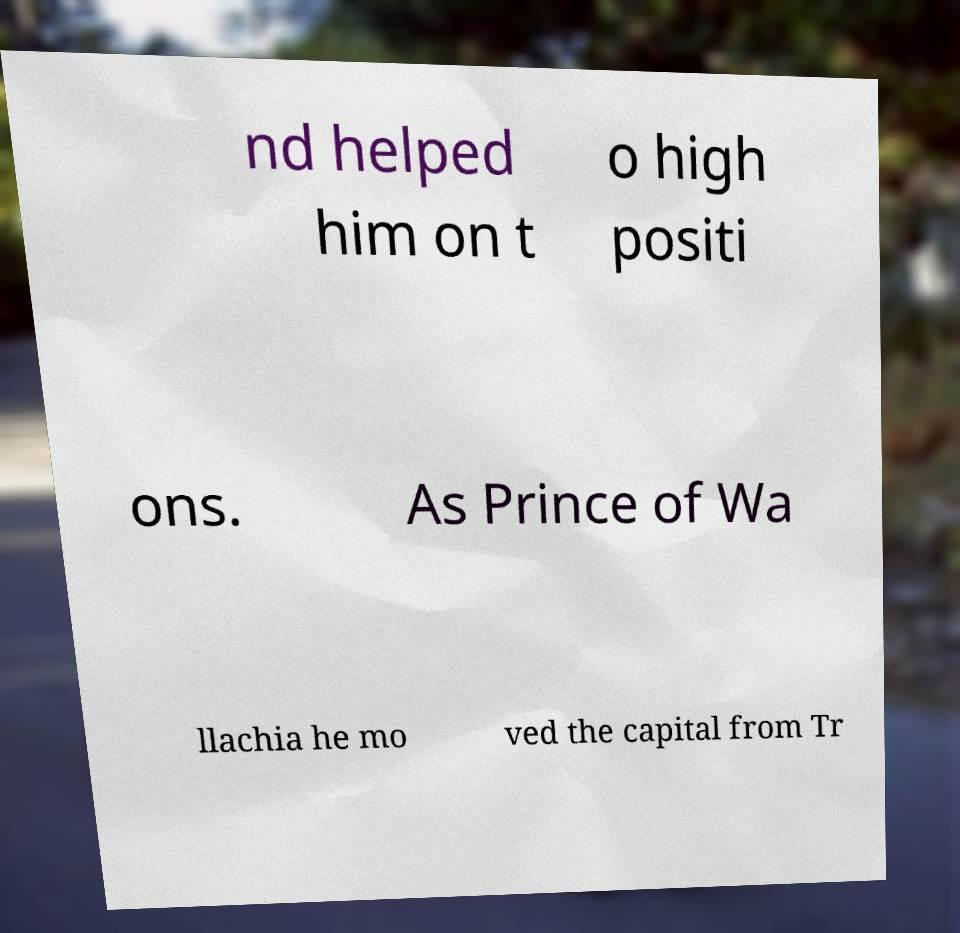I need the written content from this picture converted into text. Can you do that? nd helped him on t o high positi ons. As Prince of Wa llachia he mo ved the capital from Tr 